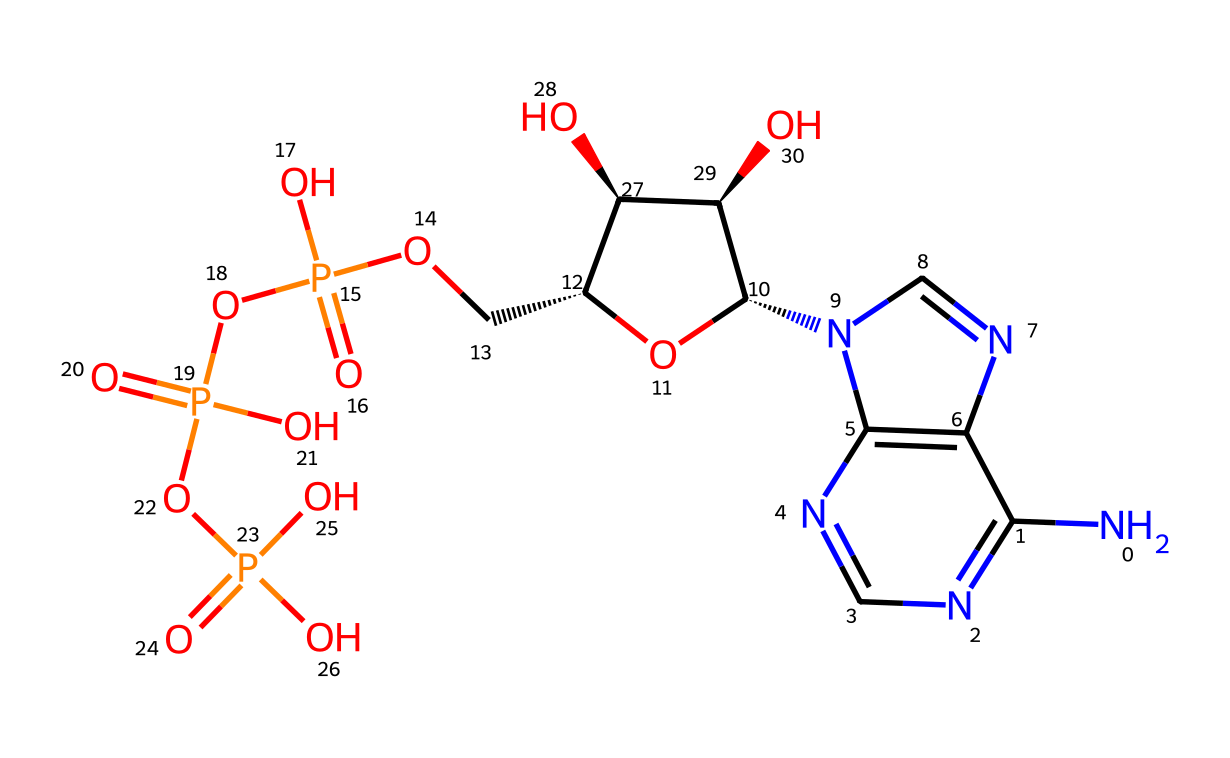What is the total number of phosphorus atoms in ATP? By examining the structure, we can locate the phosphorus (P) symbols in the chemical representation. There are a total of three 'P' atoms visible in the molecular structure of ATP.
Answer: three What is the main role of ATP in living organisms? ATP serves as the primary energy currency, providing energy for various biochemical processes in cells. This is commonly known and accepted in biochemical contexts.
Answer: energy currency How many oxygen atoms are attached to the phosphorus atoms in this structure? In the chemical structure of ATP, each phosphorus (P) atom is bonded to four oxygen (O) atoms, totaling twelve oxygen atoms connected to the three phosphorus.
Answer: twelve Which part of the ATP structure is responsible for its energy release? The high-energy bonds between the second and third phosphate groups are specifically critical for ATP's energy release when hydrolyzed, noted as important in biochemistry.
Answer: phosphate bonds What is the chemical formula of adenosine triphosphate? By counting the atoms represented in the SMILES, we find the molecular formula of ATP is C10H15N5O13P3, which combines all the carbon, hydrogen, nitrogen, oxygen, and phosphorus atoms.
Answer: C10H15N5O13P3 How many rings are there in the adenosine portion of ATP? The adenosine section contains two fused ring structures, which are characteristic of the purine structure. This is derived from visual observation of the rings in the SMILES.
Answer: two Which group of atoms in ATP facilitates the phosphate transfer necessary for energy transfer? The hydroxyl (-OH) groups that are attached to the ribose sugar in ATP play a crucial role in phosphate transfer, particularly during the phosphorylation processes.
Answer: hydroxyl groups 